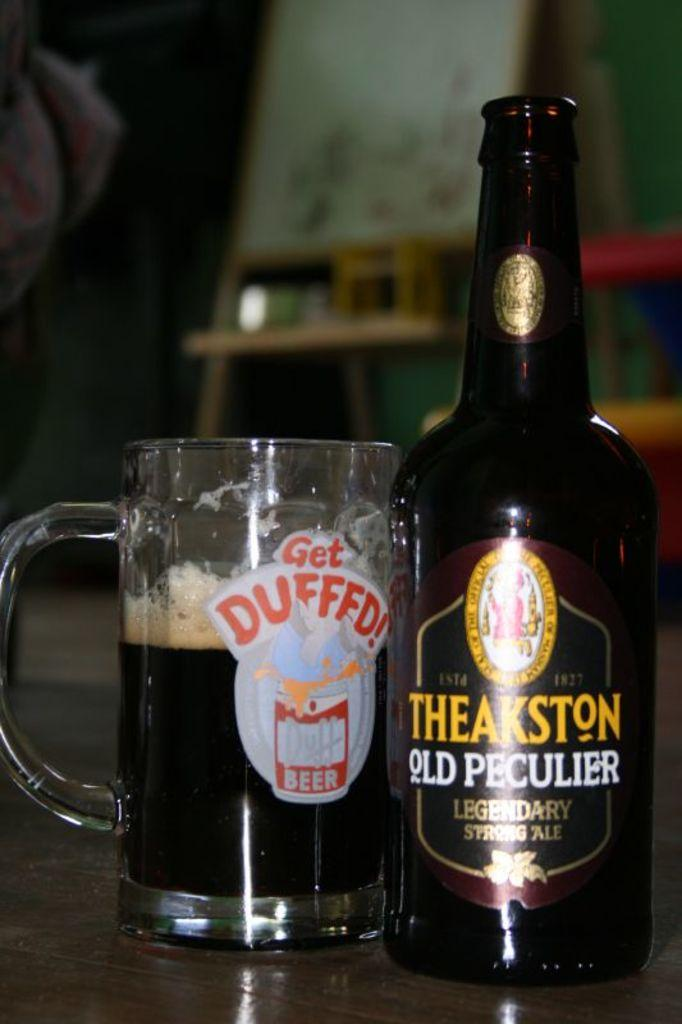<image>
Give a short and clear explanation of the subsequent image. A bottle of Theakston has been poured into a glass 